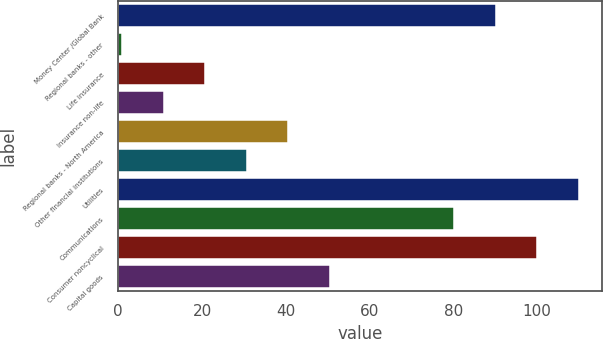Convert chart to OTSL. <chart><loc_0><loc_0><loc_500><loc_500><bar_chart><fcel>Money Center /Global Bank<fcel>Regional banks - other<fcel>Life insurance<fcel>Insurance non-life<fcel>Regional banks - North America<fcel>Other financial institutions<fcel>Utilities<fcel>Communications<fcel>Consumer noncyclical<fcel>Capital goods<nl><fcel>90.1<fcel>1<fcel>20.8<fcel>10.9<fcel>40.6<fcel>30.7<fcel>109.9<fcel>80.2<fcel>100<fcel>50.5<nl></chart> 